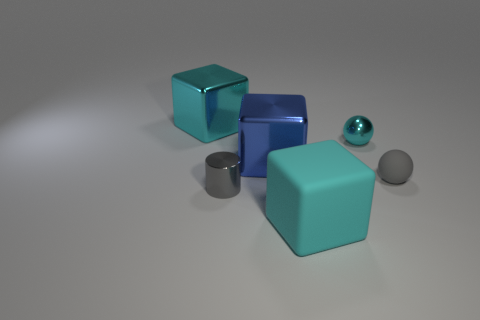How many tiny gray metallic objects are the same shape as the tiny cyan shiny object?
Your response must be concise. 0. Do the small metallic sphere and the small metal cylinder have the same color?
Your response must be concise. No. Are there any other things that are the same shape as the big blue metal object?
Your answer should be very brief. Yes. Is there a block that has the same color as the small rubber object?
Your answer should be compact. No. Is the tiny sphere left of the tiny gray matte thing made of the same material as the tiny ball that is in front of the small shiny sphere?
Provide a short and direct response. No. The tiny metallic ball is what color?
Give a very brief answer. Cyan. There is a cyan metallic thing that is to the right of the metallic block that is right of the cyan cube behind the rubber ball; what size is it?
Give a very brief answer. Small. What number of other things are there of the same size as the gray matte object?
Give a very brief answer. 2. What number of cyan balls are the same material as the big blue block?
Offer a terse response. 1. What shape is the small thing behind the gray matte object?
Keep it short and to the point. Sphere. 